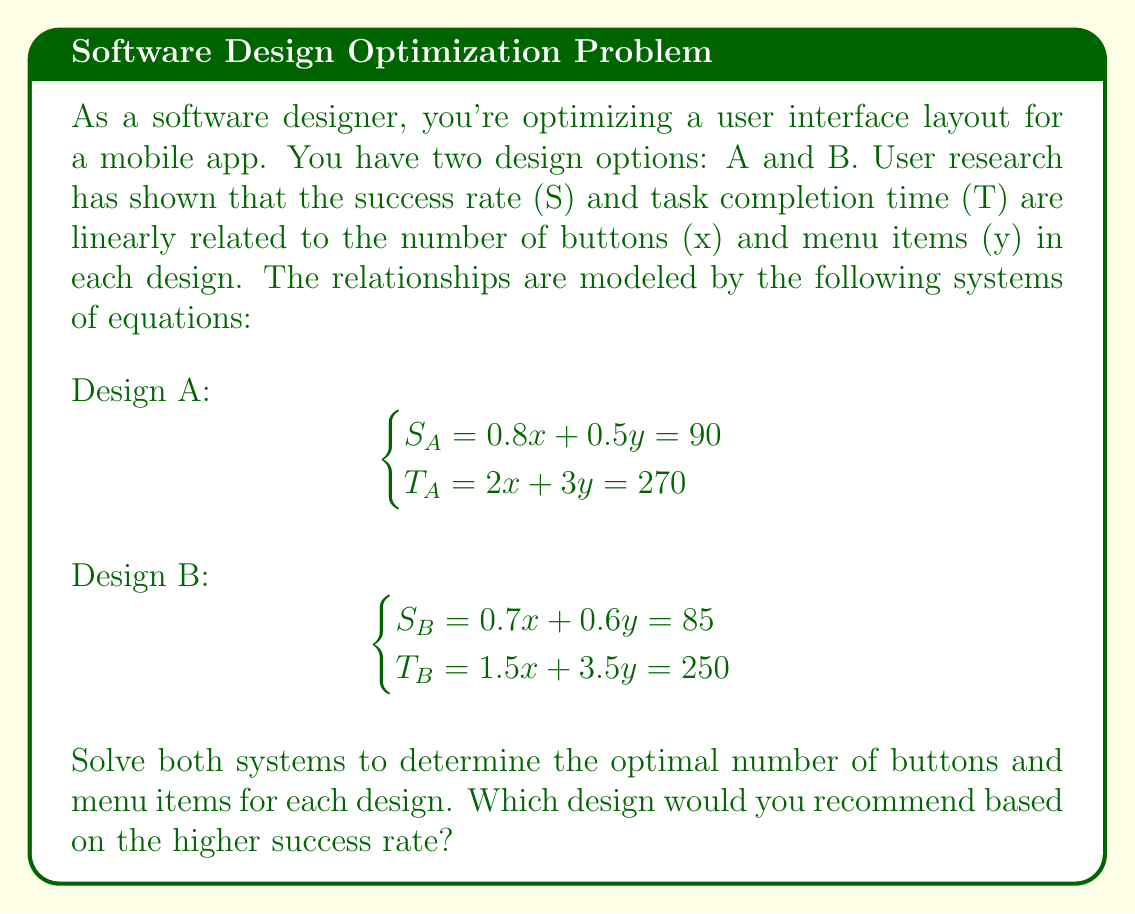Give your solution to this math problem. Let's solve each system of equations using the substitution method:

Design A:
$$\begin{cases}
0.8x + 0.5y = 90 \quad (1) \\
2x + 3y = 270 \quad (2)
\end{cases}$$

From equation (1), we can express x in terms of y:
$$0.8x + 0.5y = 90$$
$$0.8x = 90 - 0.5y$$
$$x = 112.5 - 0.625y \quad (3)$$

Substitute (3) into equation (2):
$$2(112.5 - 0.625y) + 3y = 270$$
$$225 - 1.25y + 3y = 270$$
$$225 + 1.75y = 270$$
$$1.75y = 45$$
$$y = 25.71$$

Rounding to the nearest whole number (since we can't have fractional buttons or menu items), y = 26.

Substitute y = 26 back into equation (3):
$$x = 112.5 - 0.625(26) = 96.25$$

Rounding to the nearest whole number, x = 96.

Therefore, for Design A: x = 96 buttons, y = 26 menu items.

Design B:
$$\begin{cases}
0.7x + 0.6y = 85 \quad (4) \\
1.5x + 3.5y = 250 \quad (5)
\end{cases}$$

From equation (4), we can express x in terms of y:
$$0.7x + 0.6y = 85$$
$$0.7x = 85 - 0.6y$$
$$x = 121.43 - 0.857y \quad (6)$$

Substitute (6) into equation (5):
$$1.5(121.43 - 0.857y) + 3.5y = 250$$
$$182.145 - 1.2855y + 3.5y = 250$$
$$182.145 + 2.2145y = 250$$
$$2.2145y = 67.855$$
$$y = 30.64$$

Rounding to the nearest whole number, y = 31.

Substitute y = 31 back into equation (6):
$$x = 121.43 - 0.857(31) = 94.86$$

Rounding to the nearest whole number, x = 95.

Therefore, for Design B: x = 95 buttons, y = 31 menu items.

To determine which design has a higher success rate, let's calculate the success rate for each design using the original equations:

Design A: $S_A = 0.8(96) + 0.5(26) = 76.8 + 13 = 89.8$
Design B: $S_B = 0.7(95) + 0.6(31) = 66.5 + 18.6 = 85.1$

Design A has a higher success rate of 89.8% compared to Design B's 85.1%.
Answer: Design A with 96 buttons and 26 menu items is recommended, as it has a higher success rate of 89.8% compared to Design B's 85.1%. 